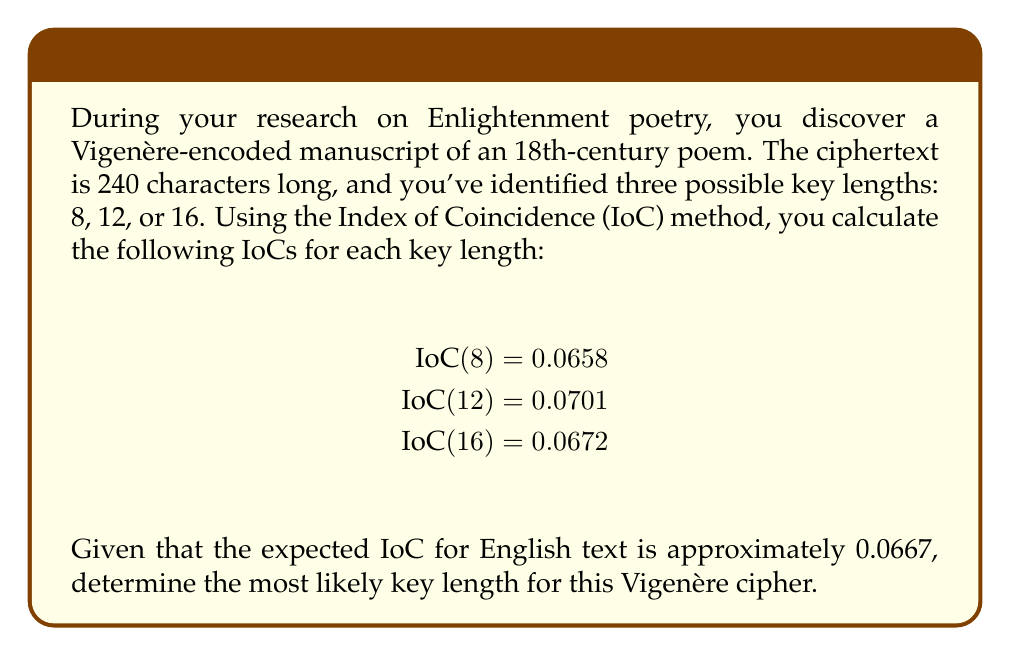Could you help me with this problem? To determine the most likely key length, we need to compare the calculated IoCs with the expected IoC for English text. The key length that produces an IoC closest to 0.0667 is the most probable.

Let's calculate the difference between each IoC and the expected value:

1. For key length 8:
   $|0.0658 - 0.0667| = 0.0009$

2. For key length 12:
   $|0.0701 - 0.0667| = 0.0034$

3. For key length 16:
   $|0.0672 - 0.0667| = 0.0005$

The smallest difference corresponds to the most likely key length. In this case, the key length of 16 has the smallest difference (0.0005) from the expected IoC.

Therefore, the most likely key length for this Vigenère cipher is 16 characters.
Answer: 16 